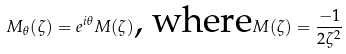Convert formula to latex. <formula><loc_0><loc_0><loc_500><loc_500>M _ { \theta } ( \zeta ) = e ^ { i \theta } M ( \zeta ) \text {, where} M ( \zeta ) = \frac { - 1 } { 2 \zeta ^ { 2 } }</formula> 